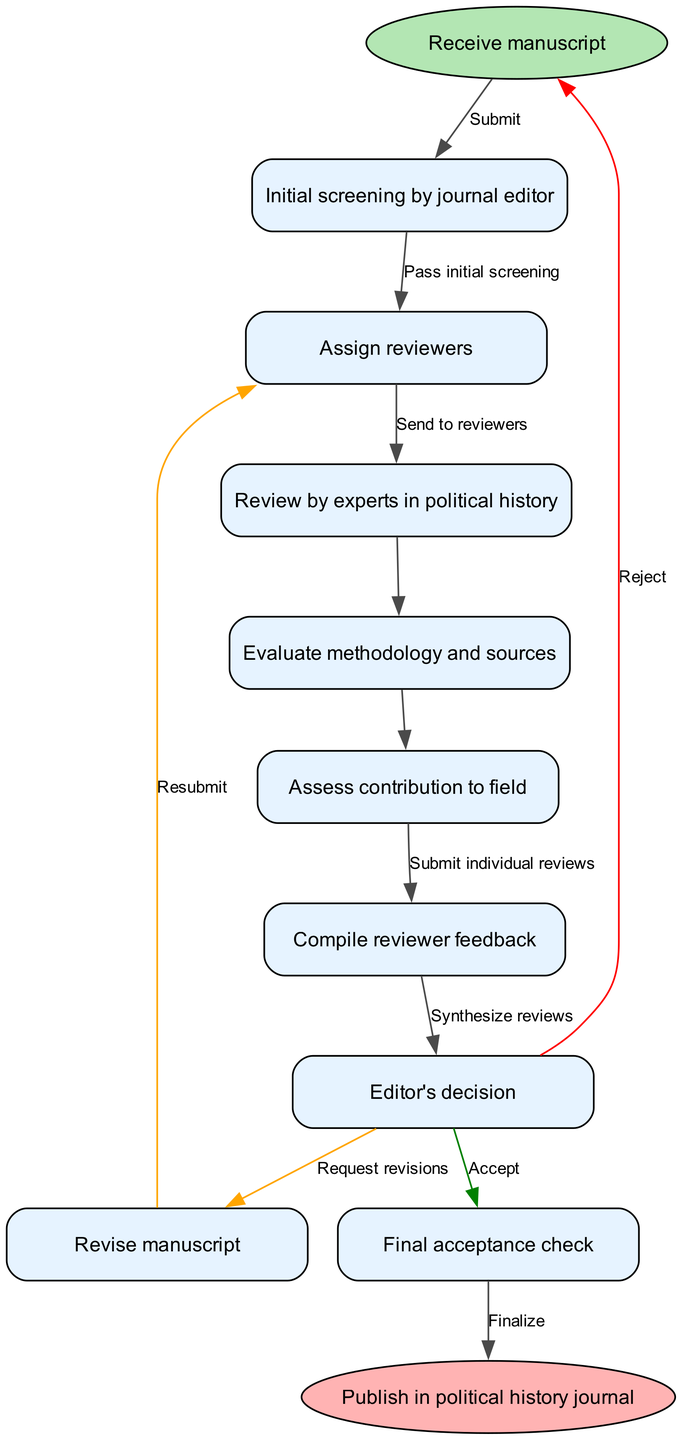What is the first step in the workflow? The diagram shows that the initial step is labeled "Receive manuscript". This indicates that the process begins with the reception of the paper submitted for review.
Answer: Receive manuscript How many nodes are present in the diagram? Counting the individual elements that represent steps in the process, there are a total of 8 nodes in the workflow: the starting point, 7 process steps, and the ending point.
Answer: 9 What follows after the initial screening by the journal editor? The flowchart indicates that after the "Initial screening by journal editor", the next action is to "Assign reviewers", connecting these two nodes.
Answer: Assign reviewers What happens if the editor's decision is to reject the paper? According to the diagram, if the editor's decision is to reject the paper, it leads back to the start node, indicating that the process ends for that particular manuscript.
Answer: Reject What is required after the reviewer feedback is compiled? The flowchart specifies that after compiling reviewer feedback, the next step is to make a decision termed "Editor's decision", which involves determining the outcome based on the reviews received.
Answer: Editor's decision How many edges are there in total? The diagram lists a series of connections (edges) between the nodes, and after counting, there are 8 edges present that connect the various steps of the peer-review workflow.
Answer: 8 What type of feedback does the paper require after synthesizing reviews? The reviewer feedback will often lead to a request for "Revisions", which is a common practice in the peer-review process to enhance the manuscript.
Answer: Revisions What is the final step in the peer-review process? The concluding action in the workflow is labeled "Publish in political history journal", indicating that after all prior steps, the manuscript is finally published when accepted.
Answer: Publish in political history journal What happens after the manuscript is resubmitted? In the diagram, once the manuscript is resubmitted, it returns to the "Editor's decision" node, meaning the process will reassess the manuscript based on the revisions made.
Answer: Editor's decision 